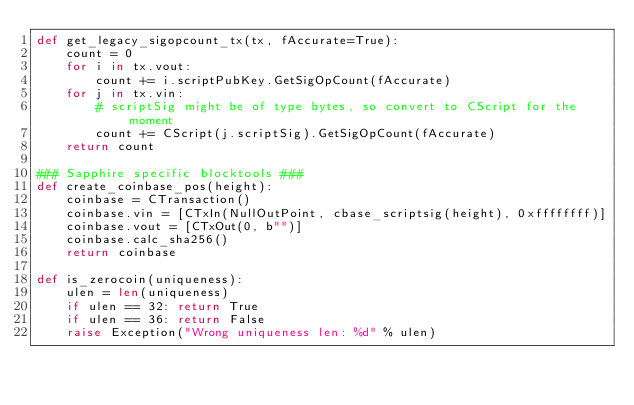Convert code to text. <code><loc_0><loc_0><loc_500><loc_500><_Python_>def get_legacy_sigopcount_tx(tx, fAccurate=True):
    count = 0
    for i in tx.vout:
        count += i.scriptPubKey.GetSigOpCount(fAccurate)
    for j in tx.vin:
        # scriptSig might be of type bytes, so convert to CScript for the moment
        count += CScript(j.scriptSig).GetSigOpCount(fAccurate)
    return count

### Sapphire specific blocktools ###
def create_coinbase_pos(height):
    coinbase = CTransaction()
    coinbase.vin = [CTxIn(NullOutPoint, cbase_scriptsig(height), 0xffffffff)]
    coinbase.vout = [CTxOut(0, b"")]
    coinbase.calc_sha256()
    return coinbase

def is_zerocoin(uniqueness):
    ulen = len(uniqueness)
    if ulen == 32: return True
    if ulen == 36: return False
    raise Exception("Wrong uniqueness len: %d" % ulen)</code> 